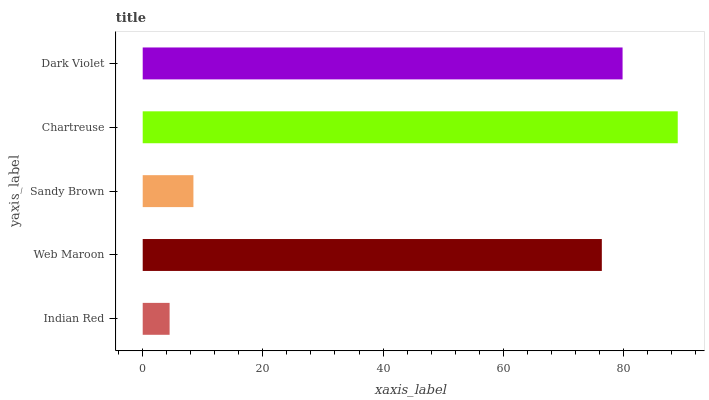Is Indian Red the minimum?
Answer yes or no. Yes. Is Chartreuse the maximum?
Answer yes or no. Yes. Is Web Maroon the minimum?
Answer yes or no. No. Is Web Maroon the maximum?
Answer yes or no. No. Is Web Maroon greater than Indian Red?
Answer yes or no. Yes. Is Indian Red less than Web Maroon?
Answer yes or no. Yes. Is Indian Red greater than Web Maroon?
Answer yes or no. No. Is Web Maroon less than Indian Red?
Answer yes or no. No. Is Web Maroon the high median?
Answer yes or no. Yes. Is Web Maroon the low median?
Answer yes or no. Yes. Is Sandy Brown the high median?
Answer yes or no. No. Is Sandy Brown the low median?
Answer yes or no. No. 